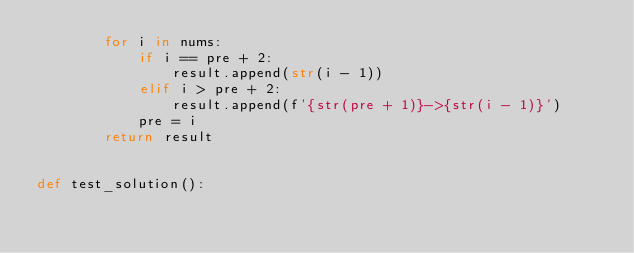Convert code to text. <code><loc_0><loc_0><loc_500><loc_500><_Python_>        for i in nums:
            if i == pre + 2:
                result.append(str(i - 1))
            elif i > pre + 2:
                result.append(f'{str(pre + 1)}->{str(i - 1)}')
            pre = i
        return result


def test_solution():</code> 